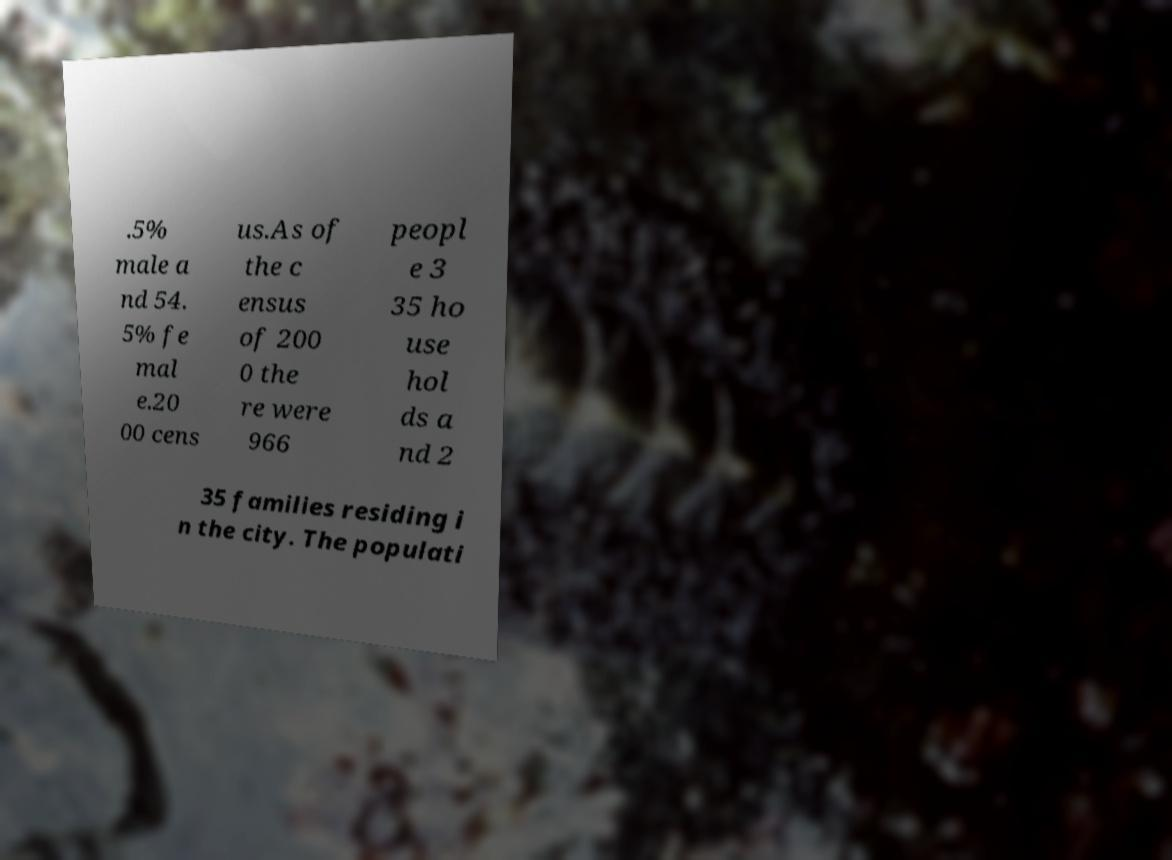Could you extract and type out the text from this image? .5% male a nd 54. 5% fe mal e.20 00 cens us.As of the c ensus of 200 0 the re were 966 peopl e 3 35 ho use hol ds a nd 2 35 families residing i n the city. The populati 